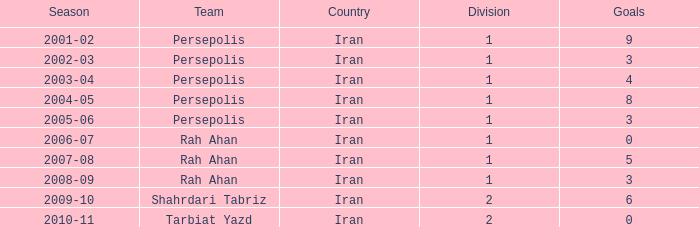What is the lowest Division, when Goals is less than 5, and when Season is "2002-03"? 1.0. 